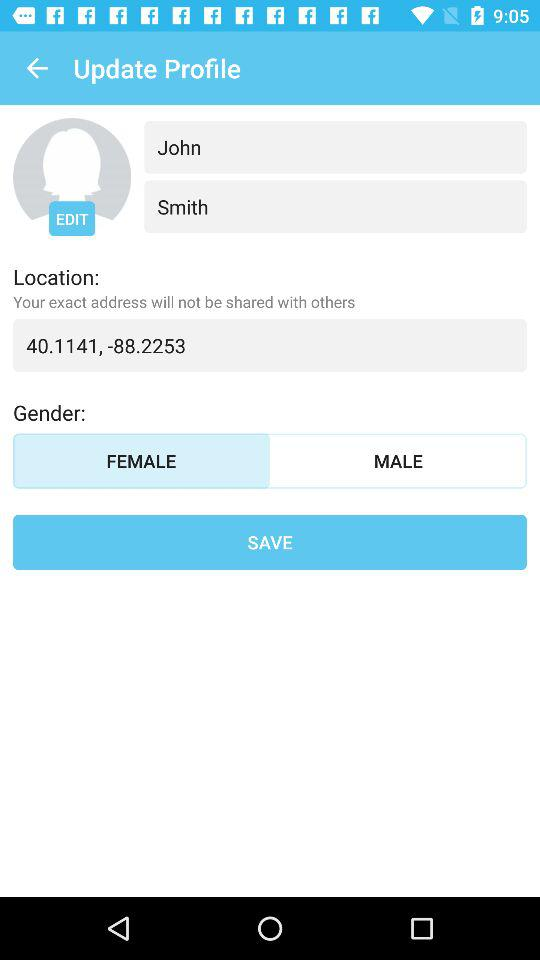What is the gender? The gender is female. 